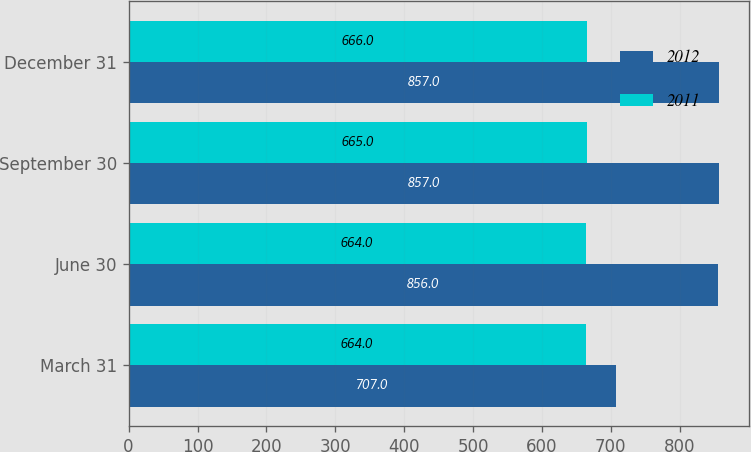<chart> <loc_0><loc_0><loc_500><loc_500><stacked_bar_chart><ecel><fcel>March 31<fcel>June 30<fcel>September 30<fcel>December 31<nl><fcel>2012<fcel>707<fcel>856<fcel>857<fcel>857<nl><fcel>2011<fcel>664<fcel>664<fcel>665<fcel>666<nl></chart> 